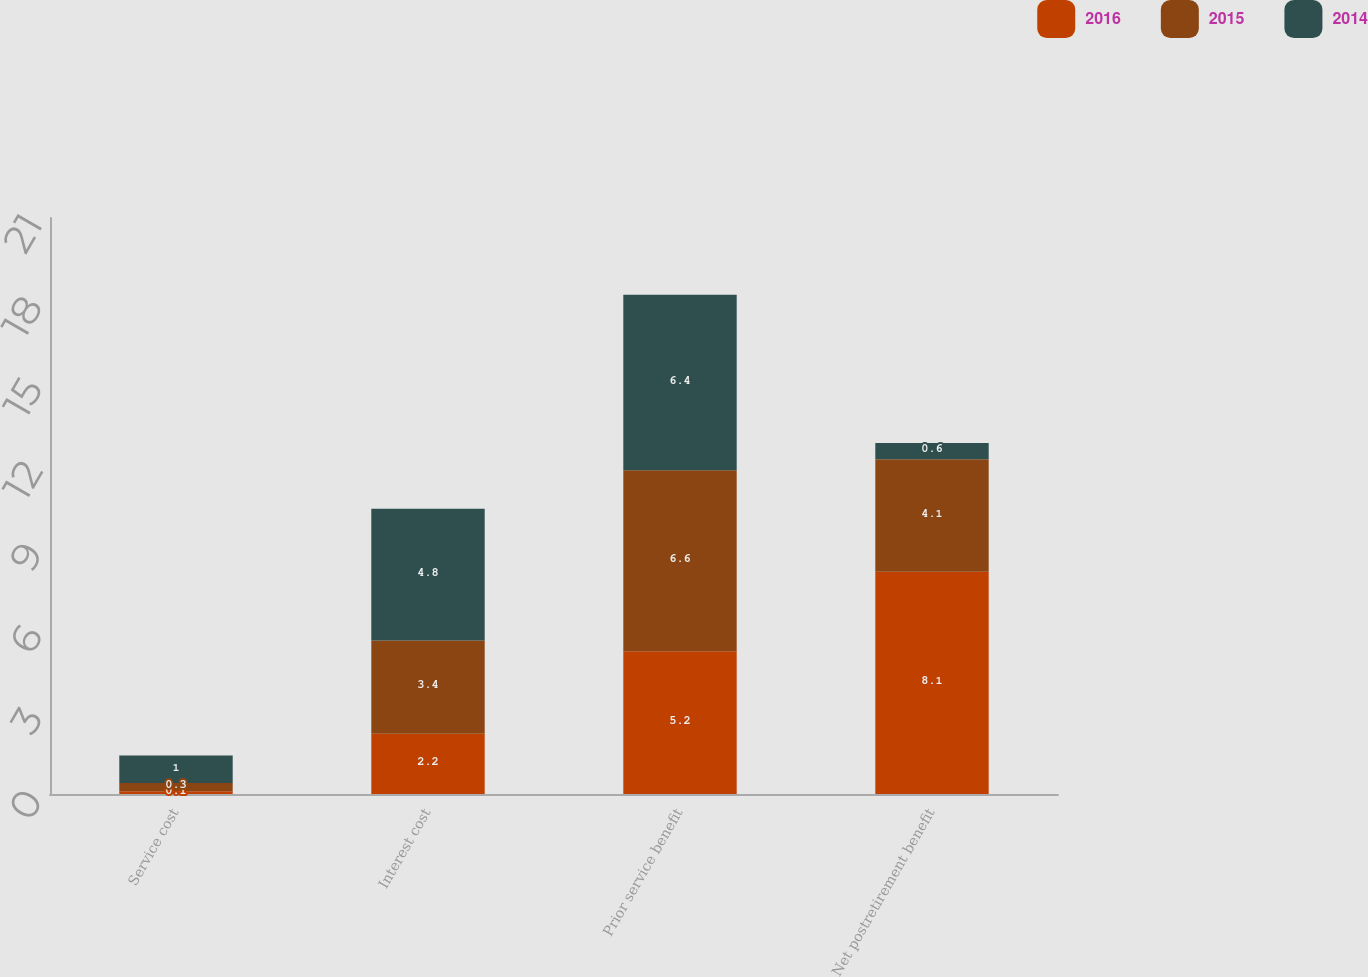<chart> <loc_0><loc_0><loc_500><loc_500><stacked_bar_chart><ecel><fcel>Service cost<fcel>Interest cost<fcel>Prior service benefit<fcel>Net postretirement benefit<nl><fcel>2016<fcel>0.1<fcel>2.2<fcel>5.2<fcel>8.1<nl><fcel>2015<fcel>0.3<fcel>3.4<fcel>6.6<fcel>4.1<nl><fcel>2014<fcel>1<fcel>4.8<fcel>6.4<fcel>0.6<nl></chart> 